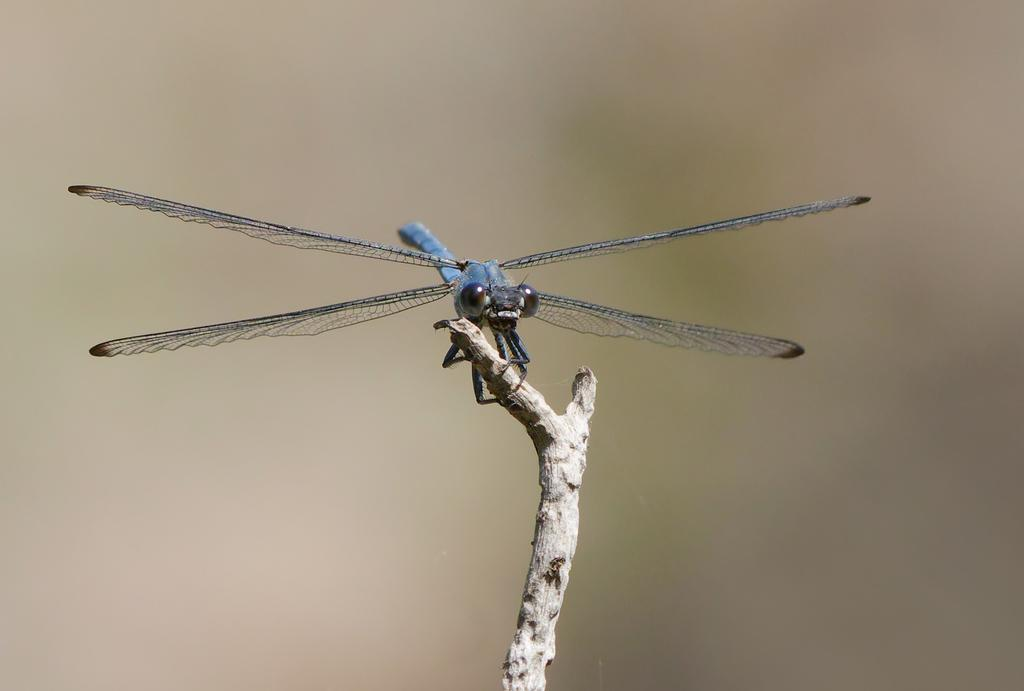What is the main subject of the image? There is a dragonfly in the image. Where is the dragonfly located? The dragonfly is on a stick. Can you describe the background of the image? The background of the image is blurred. What type of force can be seen pushing the dragonfly in the image? There is no force pushing the dragonfly in the image; it is stationary on the stick. 